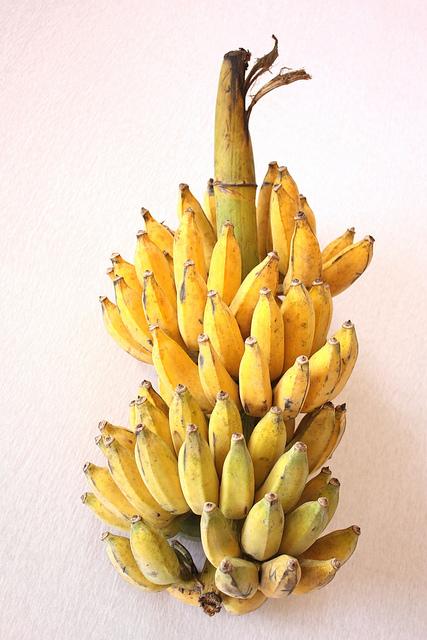Is there any other colors besides yellow in the picture?
Be succinct. Yes. How many different fruits do you see?
Short answer required. 1. How many bananas are there?
Short answer required. 53. Is this called a bunch?
Answer briefly. Yes. Is the banana fresh off the tree?
Short answer required. Yes. Why are the bananas different colors?
Be succinct. Some are ripe. 